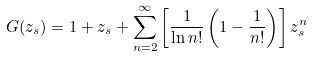Convert formula to latex. <formula><loc_0><loc_0><loc_500><loc_500>G ( z _ { s } ) & = 1 + z _ { s } + \sum _ { n = 2 } ^ { \infty } \left [ \frac { 1 } { \ln n ! } \left ( 1 - \frac { 1 } { n ! } \right ) \right ] z _ { s } ^ { n }</formula> 